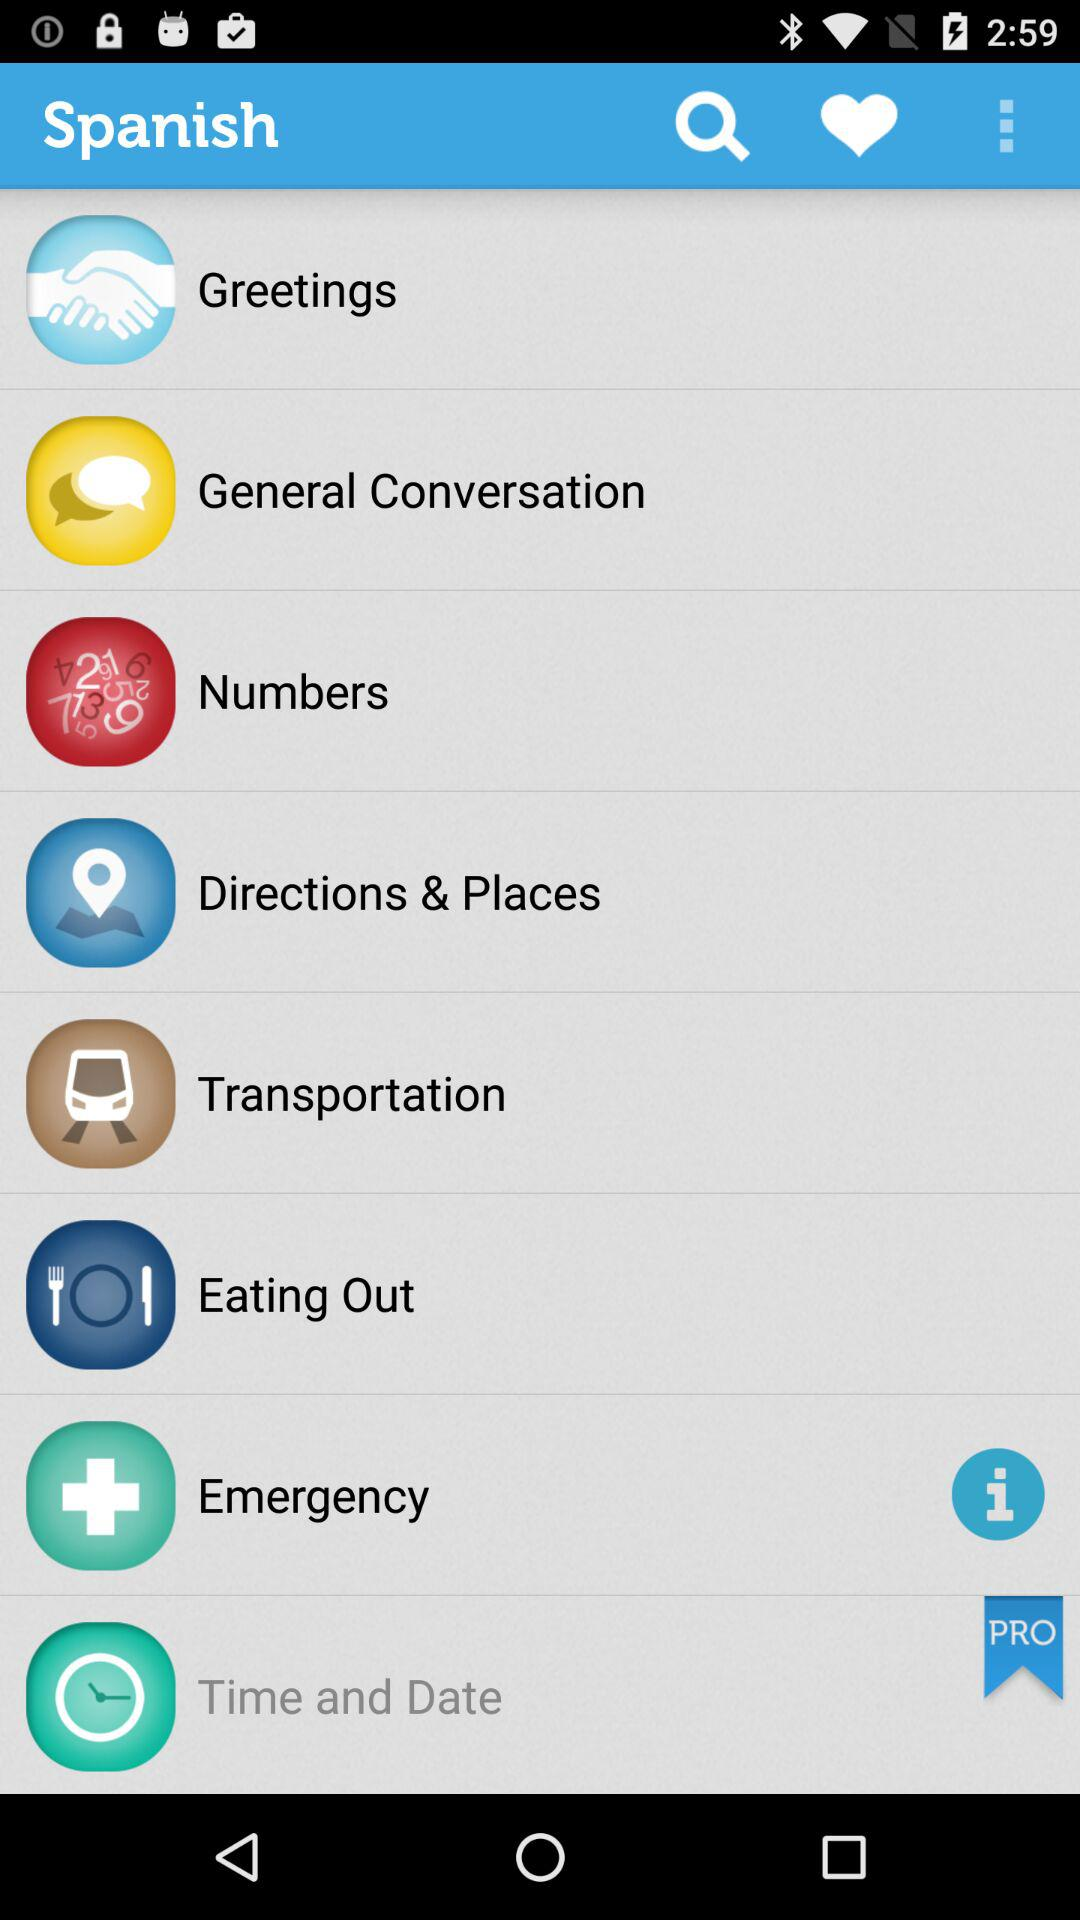What is the name of the application? The name of the application is "Spanish". 